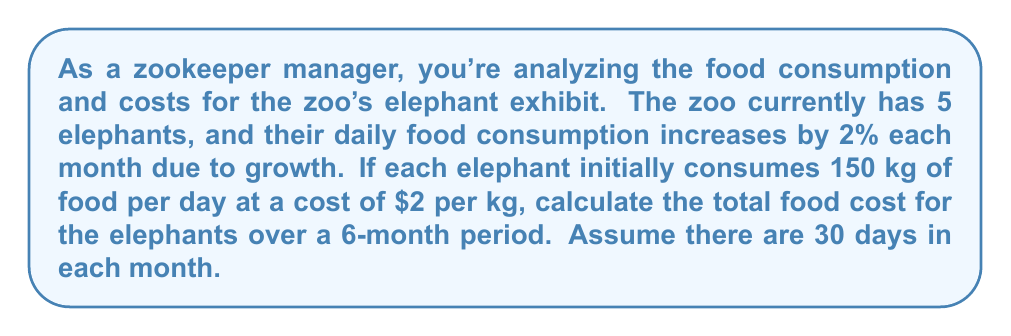Could you help me with this problem? Let's approach this step-by-step using the concept of geometric series:

1) Initial daily consumption for all elephants:
   $150 \text{ kg} \times 5 \text{ elephants} = 750 \text{ kg}$

2) Monthly consumption increase: 2% = 0.02

3) We need to calculate the consumption for each month and sum it up:

   Month 1: $750 \times 30 = 22500 \text{ kg}$
   Month 2: $750 \times 1.02 \times 30 = 22950 \text{ kg}$
   Month 3: $750 \times 1.02^2 \times 30 = 23409 \text{ kg}$
   ...
   Month 6: $750 \times 1.02^5 \times 30 = 24877.81 \text{ kg}$

4) This forms a geometric series with:
   First term $a = 22500$
   Common ratio $r = 1.02$
   Number of terms $n = 6$

5) The sum of a geometric series is given by:
   $$S_n = \frac{a(1-r^n)}{1-r}$$

6) Substituting our values:
   $$S_6 = \frac{22500(1-1.02^6)}{1-1.02} = 138,635.39 \text{ kg}$$

7) To get the total cost, multiply by $2 per kg:
   $138,635.39 \times 2 = 277,270.78$
Answer: $277,270.78 